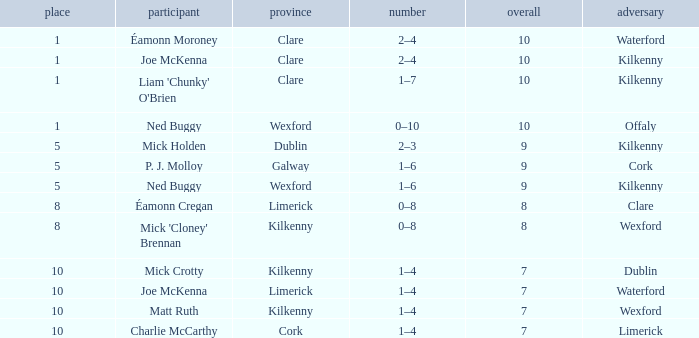I'm looking to parse the entire table for insights. Could you assist me with that? {'header': ['place', 'participant', 'province', 'number', 'overall', 'adversary'], 'rows': [['1', 'Éamonn Moroney', 'Clare', '2–4', '10', 'Waterford'], ['1', 'Joe McKenna', 'Clare', '2–4', '10', 'Kilkenny'], ['1', "Liam 'Chunky' O'Brien", 'Clare', '1–7', '10', 'Kilkenny'], ['1', 'Ned Buggy', 'Wexford', '0–10', '10', 'Offaly'], ['5', 'Mick Holden', 'Dublin', '2–3', '9', 'Kilkenny'], ['5', 'P. J. Molloy', 'Galway', '1–6', '9', 'Cork'], ['5', 'Ned Buggy', 'Wexford', '1–6', '9', 'Kilkenny'], ['8', 'Éamonn Cregan', 'Limerick', '0–8', '8', 'Clare'], ['8', "Mick 'Cloney' Brennan", 'Kilkenny', '0–8', '8', 'Wexford'], ['10', 'Mick Crotty', 'Kilkenny', '1–4', '7', 'Dublin'], ['10', 'Joe McKenna', 'Limerick', '1–4', '7', 'Waterford'], ['10', 'Matt Ruth', 'Kilkenny', '1–4', '7', 'Wexford'], ['10', 'Charlie McCarthy', 'Cork', '1–4', '7', 'Limerick']]} What is galway county's total? 9.0. 